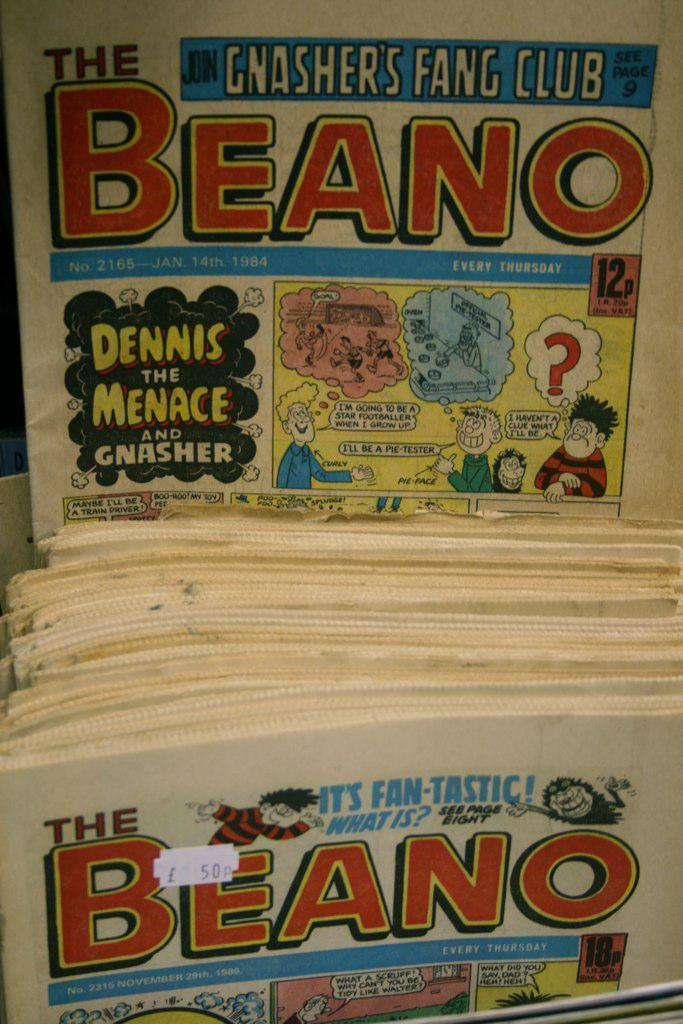<image>
Share a concise interpretation of the image provided. A comic book features a Dennis the Menace story. 